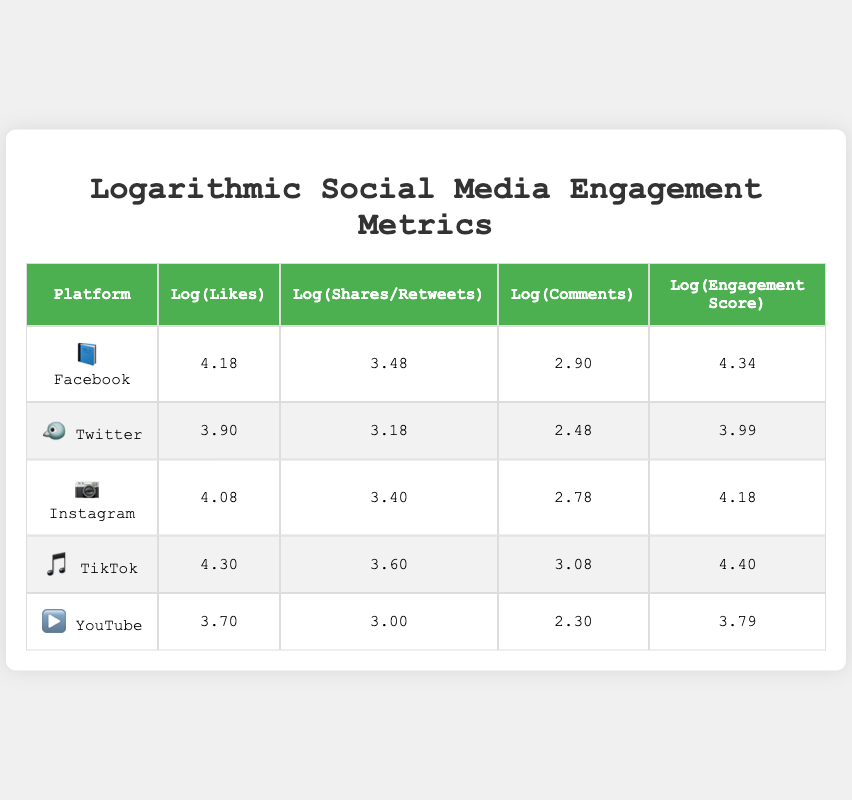What is the logarithmic value of likes for Instagram? The table shows that the logarithmic value of likes for Instagram is listed under the "Log(Likes)" column. Referring to the table, it clearly states this value as 4.08.
Answer: 4.08 Which platform has the highest logarithmic engagement score? By examining the "Log(Engagement Score)" column, I can see that TikTok has the highest value at 4.40 compared to others.
Answer: TikTok How many logarithmic shares does Facebook have compared to YouTube? Facebook has a logarithmic share value of 3.48, while YouTube has 3.00. The difference can be calculated by subtracting: 3.48 - 3.00 = 0.48.
Answer: 0.48 Is the logarithmic comments value for TikTok greater than that for Twitter? Checking the values, TikTok has a logarithmic comments value of 3.08, while Twitter has 2.48. Since 3.08 is greater than 2.48, the statement is true.
Answer: Yes What is the average logarithmic value of likes across all platforms? To find the average, I add all the logarithmic like values: (4.18 + 3.90 + 4.08 + 4.30 + 3.70) = 20.14. Then I divide by the number of platforms (5): 20.14 / 5 = 4.03.
Answer: 4.03 Which platform has the lowest logarithmic comments value? The "Log(Comments)" column shows the values: Facebook (2.90), Twitter (2.48), Instagram (2.78), TikTok (3.08), and YouTube (2.30). YouTube has the lowest value at 2.30.
Answer: YouTube How much greater is TikTok's logarithmic shares value compared to Facebook's? TikTok has a logarithmic shares value of 3.60 and Facebook has 3.48. The difference is calculated as: 3.60 - 3.48 = 0.12.
Answer: 0.12 Are the logarithmic values for engagement scores of Instagram and Twitter equal? Looking at the "Log(Engagement Score)" column, Instagram has 4.18, while Twitter has 3.99. Since these values are not equal, the statement is false.
Answer: No What is the median of the logarithmic values of shares from all platforms? The values listed are: 3.48 (Facebook), 3.18 (Twitter), 3.40 (Instagram), 3.60 (TikTok), and 3.00 (YouTube). Sorting these gives us: 3.00, 3.18, 3.40, 3.48, 3.60. The median, which is the middle value in this list, is 3.40.
Answer: 3.40 